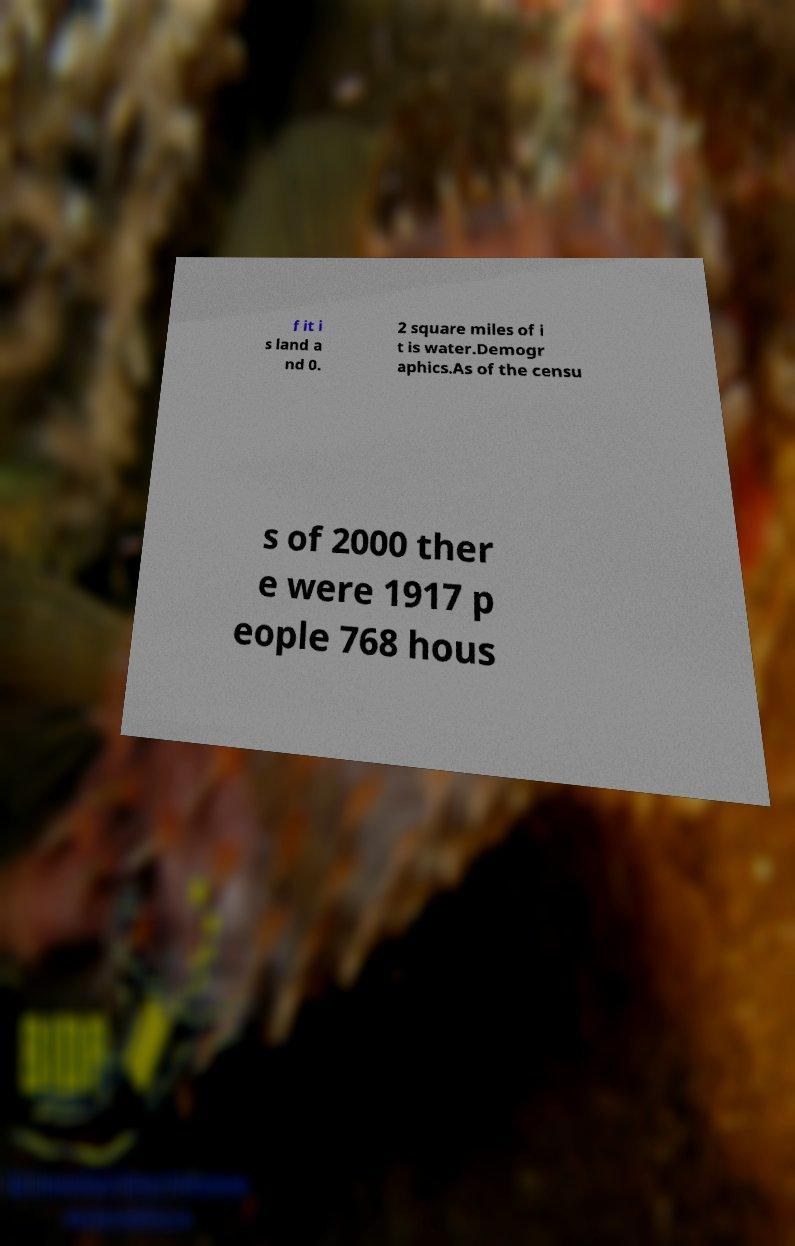For documentation purposes, I need the text within this image transcribed. Could you provide that? f it i s land a nd 0. 2 square miles of i t is water.Demogr aphics.As of the censu s of 2000 ther e were 1917 p eople 768 hous 